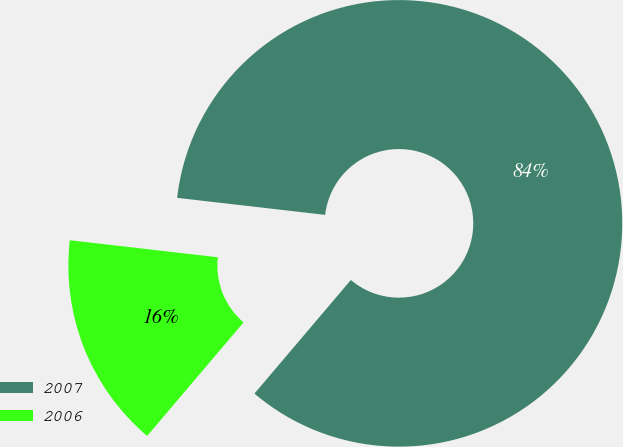Convert chart. <chart><loc_0><loc_0><loc_500><loc_500><pie_chart><fcel>2007<fcel>2006<nl><fcel>84.38%<fcel>15.62%<nl></chart> 